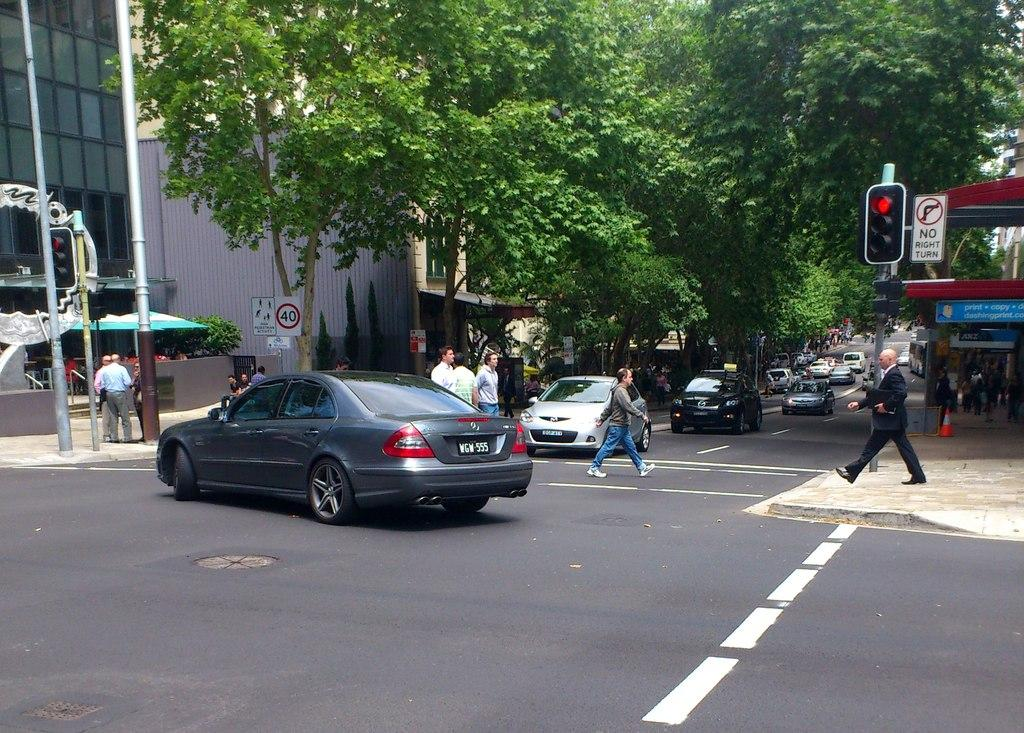What types of objects can be seen in the image? There are vehicles, signal lights, sign boards, poles, people, trees, boards, and buildings in the image. What are the vehicles doing in the image? The vehicles are on the road in the image. Can you describe the people in the image? Two people are walking in the image. What else is present in the image besides the objects and people mentioned? Trees are present in the image. How does the image contribute to pollution? The image itself does not contribute to pollution; it is a static representation of a scene. What form does the profit take in the image? There is no mention of profit in the image, as it is a visual representation of a scene and not related to financial matters. 